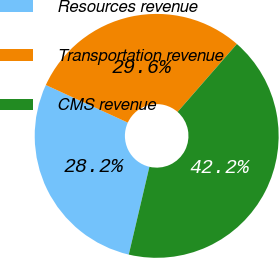<chart> <loc_0><loc_0><loc_500><loc_500><pie_chart><fcel>Resources revenue<fcel>Transportation revenue<fcel>CMS revenue<nl><fcel>28.17%<fcel>29.58%<fcel>42.25%<nl></chart> 